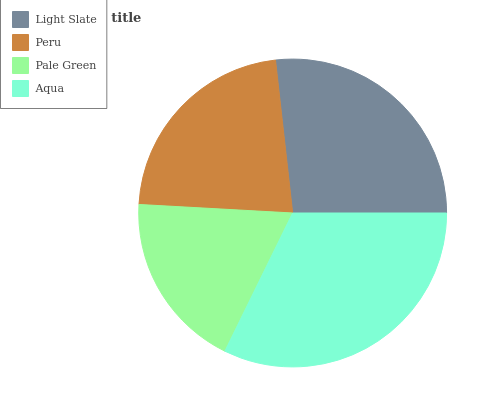Is Pale Green the minimum?
Answer yes or no. Yes. Is Aqua the maximum?
Answer yes or no. Yes. Is Peru the minimum?
Answer yes or no. No. Is Peru the maximum?
Answer yes or no. No. Is Light Slate greater than Peru?
Answer yes or no. Yes. Is Peru less than Light Slate?
Answer yes or no. Yes. Is Peru greater than Light Slate?
Answer yes or no. No. Is Light Slate less than Peru?
Answer yes or no. No. Is Light Slate the high median?
Answer yes or no. Yes. Is Peru the low median?
Answer yes or no. Yes. Is Aqua the high median?
Answer yes or no. No. Is Light Slate the low median?
Answer yes or no. No. 